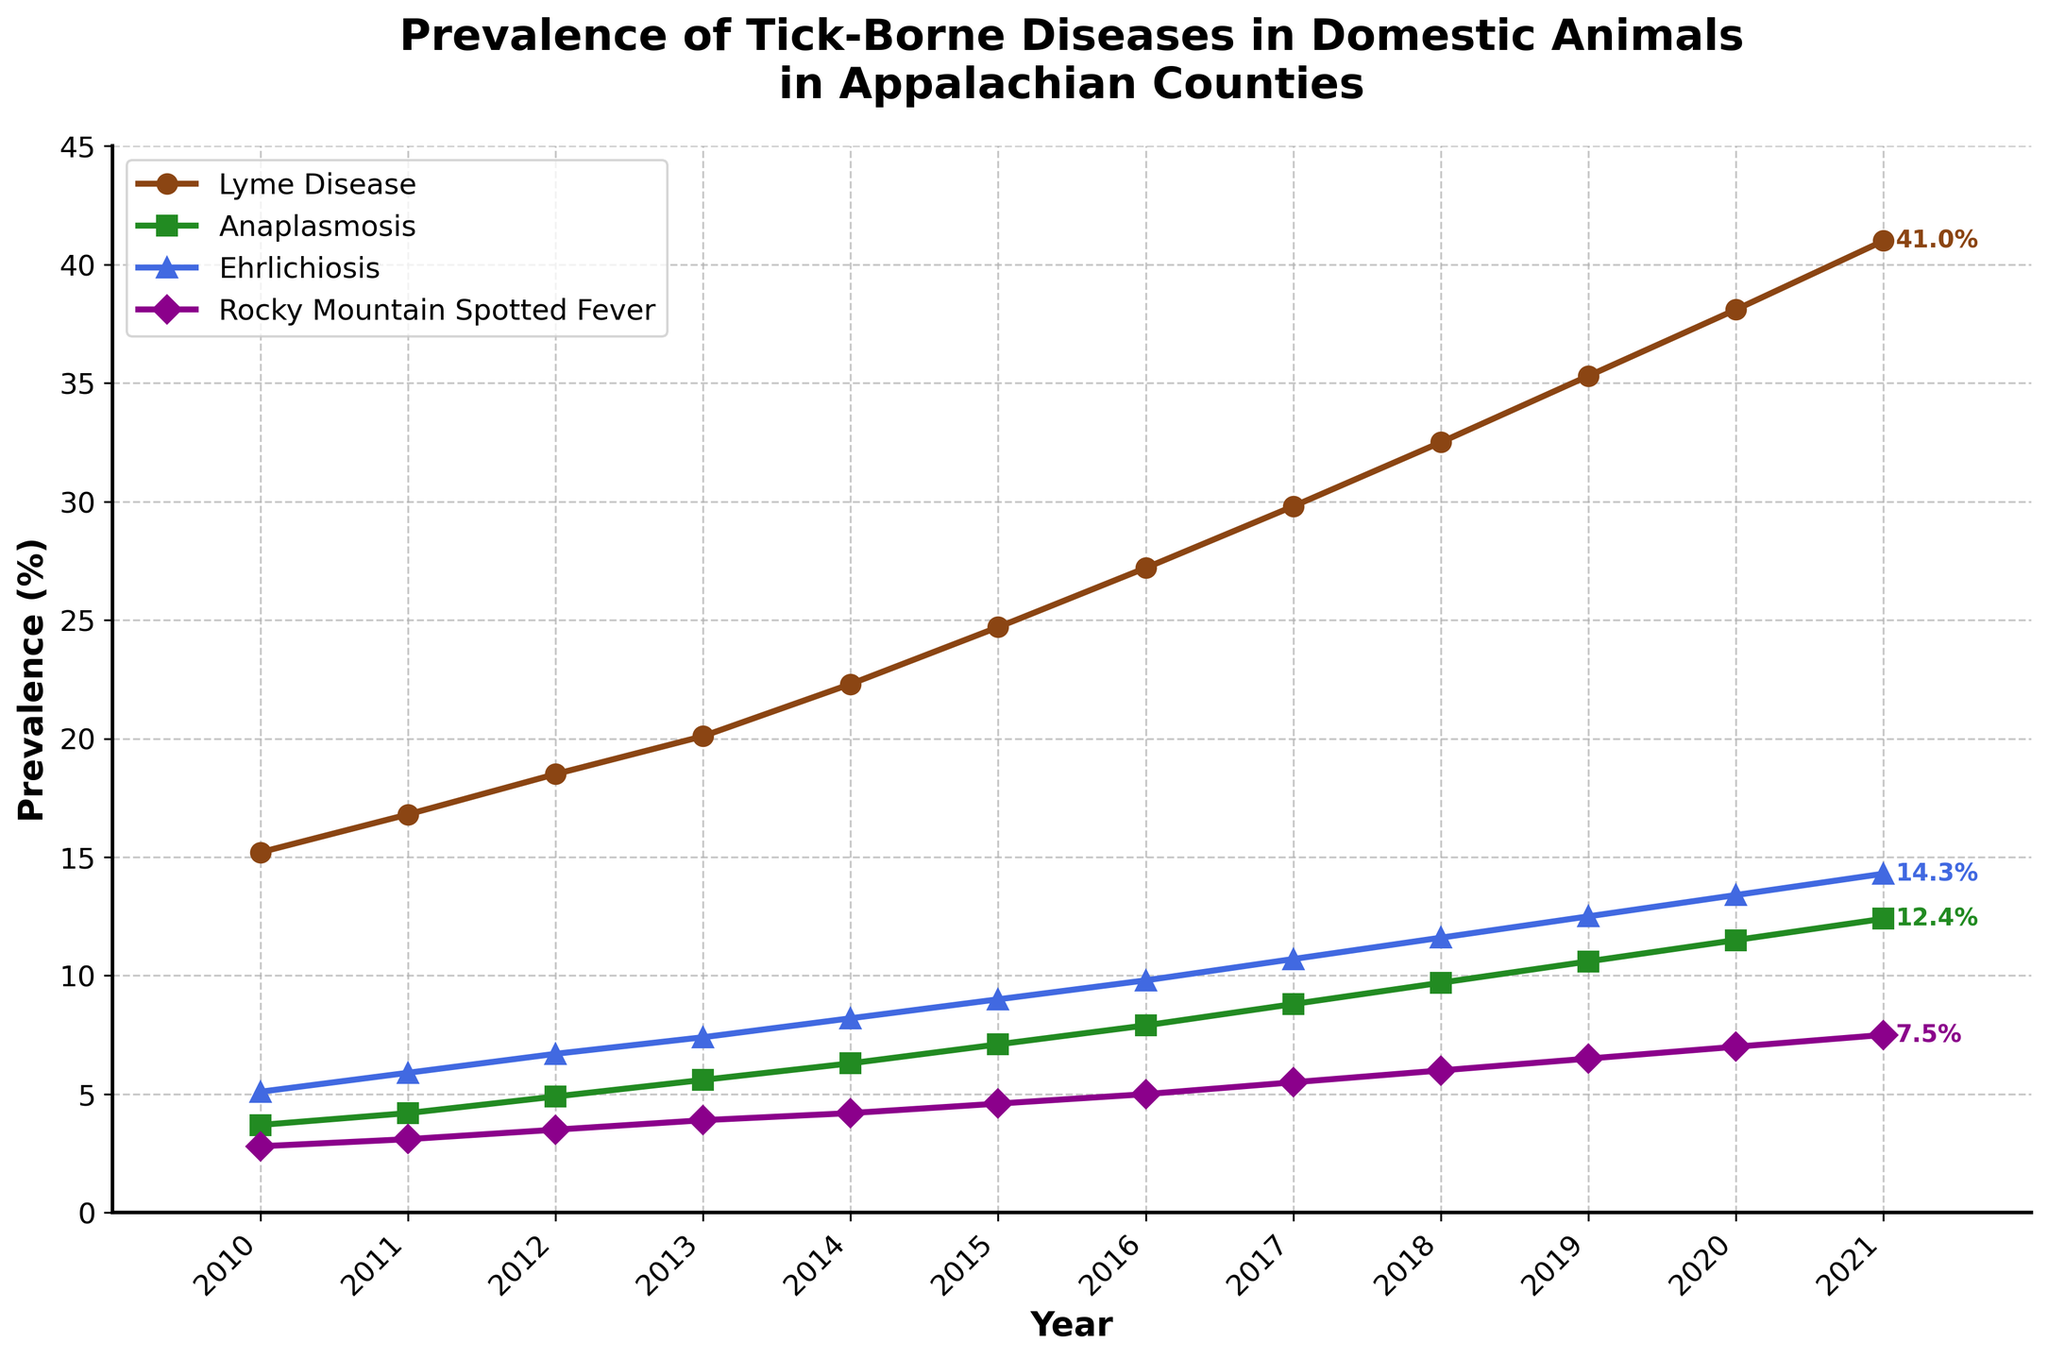What year did Lyme Disease first reach or exceed a prevalence of 40%? From the plot, identify the year when the line representing Lyme Disease crosses the 40% mark on the y-axis.
Answer: 2021 How has the prevalence of Rocky Mountain Spotted Fever changed from 2010 to 2021? Look at the start and end points of the Rocky Mountain Spotted Fever line (purple, diamond marker). In 2010 it was around 2.8%, and in 2021 it reached 7.5%. Subtract the starting value from the ending value.
Answer: Increased by 4.7% Which disease had the smallest increase in prevalence from 2010 to 2021? Calculate the difference for each disease between 2010 and 2021. Lyme Disease (41.0 - 15.2), Anaplasmosis (12.4 - 3.7), Ehrlichiosis (14.3 - 5.1), Rocky Mountain Spotted Fever (7.5 - 2.8). Find the smallest difference.
Answer: Rocky Mountain Spotted Fever What was the average prevalence of Ehrlichiosis across the years 2013 to 2015? Add the prevalence values for Ehrlichiosis from 2013 (7.4), 2014 (8.2), and 2015 (9.0). Divide the sum by the number of years (3).
Answer: 8.2 In 2018, which disease had the highest prevalence, and what was it? Inspect the values for each disease in 2018. Lyme Disease (32.5), Anaplasmosis (9.7), Ehrlichiosis (11.6), Rocky Mountain Spotted Fever (6.0). Identify the highest value.
Answer: Lyme Disease, 32.5% Which disease showed the most consistent yearly increase from 2010 to 2021? Look at the trend lines for each disease. Analyze the smoothness and consistency of the increase over the years. Lyme Disease shows a consistently steady rise.
Answer: Lyme Disease Compare the prevalence of Anaplasmosis and Ehrlichiosis in 2015. Which one was higher and by how much? Find the values for Anaplasmosis (7.1) and Ehrlichiosis (9.0) in 2015. Subtract the smaller value from the larger value.
Answer: Ehrlichiosis was higher by 1.9% How many years did it take for Lyme Disease to double its prevalence from its 2010 value? Identify the 2010 value for Lyme Disease (15.2). Double this value to get 30.4. Find the year when Lyme Disease first exceeds 30.4.
Answer: 8 years (2018) What was the total increase in prevalence for all four diseases combined from 2010 to 2021? Calculate the increase for each disease from 2010 to 2021: Lyme Disease (41.0 - 15.2), Anaplasmosis (12.4 - 3.7), Ehrlichiosis (14.3 - 5.1), Rocky Mountain Spotted Fever (7.5 - 2.8). Sum these increases.
Answer: 48.4% In which year did the prevalence of Anaplasmosis first exceed 10%? Review the Anaplasmosis line (green, square marker) and find the year when it crosses the 10% mark on the y-axis.
Answer: 2019 